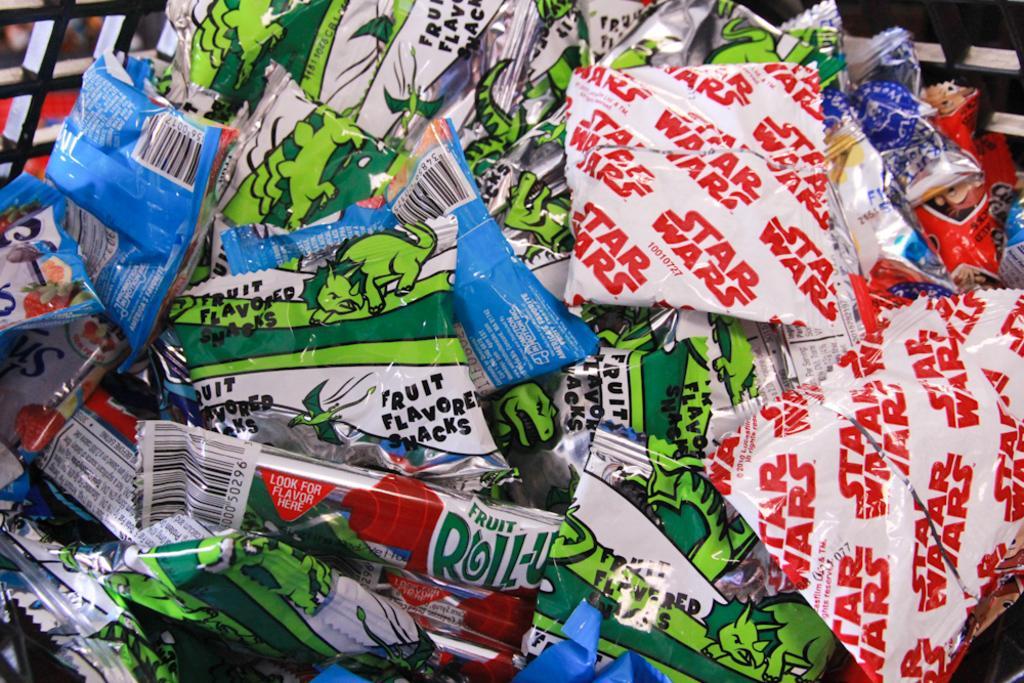How would you summarize this image in a sentence or two? In the middle of this image, there are packets in different colors arranged on a surface. On the top left, there is a fence. On the top right, there is a fence. And the background is blurred. 